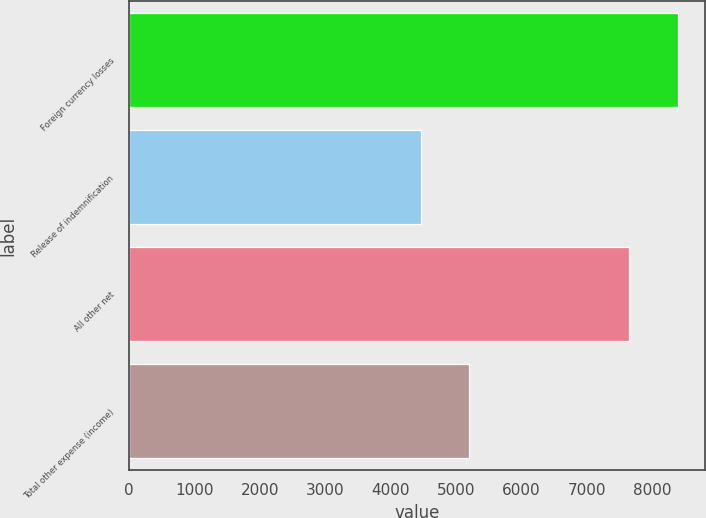Convert chart. <chart><loc_0><loc_0><loc_500><loc_500><bar_chart><fcel>Foreign currency losses<fcel>Release of indemnification<fcel>All other net<fcel>Total other expense (income)<nl><fcel>8395<fcel>4459<fcel>7649<fcel>5205<nl></chart> 